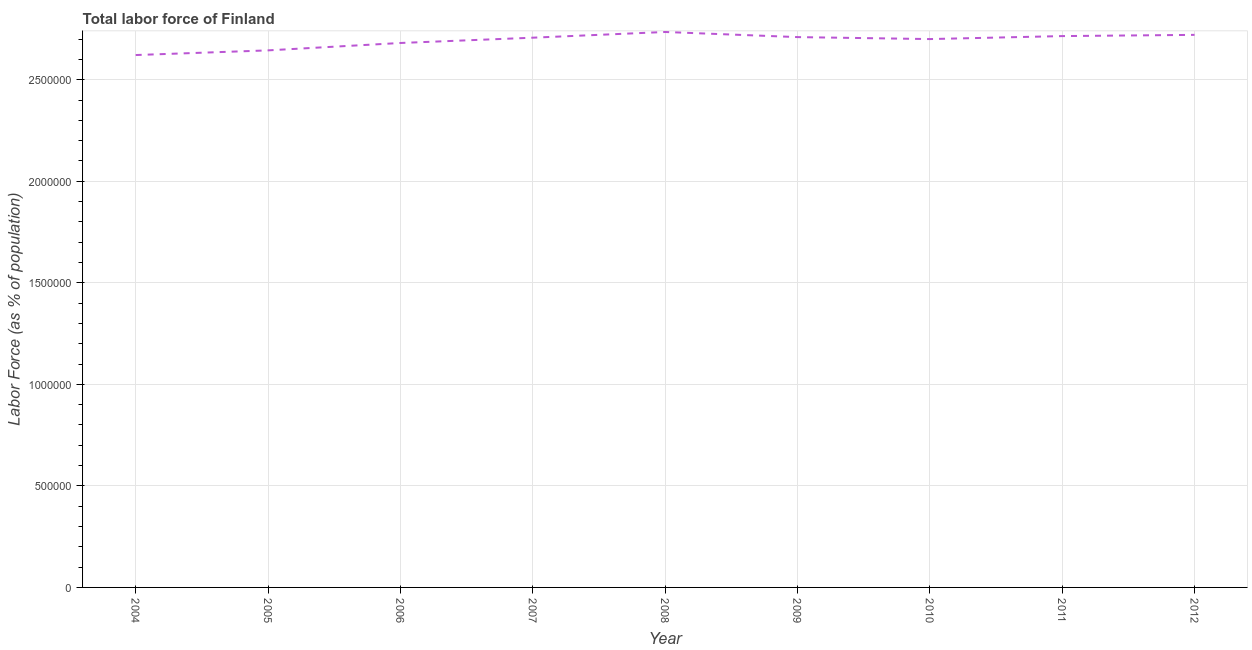What is the total labor force in 2010?
Provide a succinct answer. 2.70e+06. Across all years, what is the maximum total labor force?
Provide a succinct answer. 2.74e+06. Across all years, what is the minimum total labor force?
Offer a very short reply. 2.62e+06. In which year was the total labor force maximum?
Make the answer very short. 2008. What is the sum of the total labor force?
Offer a terse response. 2.42e+07. What is the difference between the total labor force in 2006 and 2011?
Keep it short and to the point. -3.40e+04. What is the average total labor force per year?
Offer a very short reply. 2.69e+06. What is the median total labor force?
Provide a short and direct response. 2.71e+06. In how many years, is the total labor force greater than 2300000 %?
Make the answer very short. 9. What is the ratio of the total labor force in 2005 to that in 2006?
Give a very brief answer. 0.99. Is the total labor force in 2009 less than that in 2010?
Offer a very short reply. No. What is the difference between the highest and the second highest total labor force?
Offer a terse response. 1.42e+04. Is the sum of the total labor force in 2007 and 2009 greater than the maximum total labor force across all years?
Provide a succinct answer. Yes. What is the difference between the highest and the lowest total labor force?
Ensure brevity in your answer.  1.14e+05. In how many years, is the total labor force greater than the average total labor force taken over all years?
Provide a short and direct response. 6. Does the total labor force monotonically increase over the years?
Provide a short and direct response. No. How many lines are there?
Your answer should be compact. 1. Are the values on the major ticks of Y-axis written in scientific E-notation?
Your answer should be very brief. No. What is the title of the graph?
Provide a short and direct response. Total labor force of Finland. What is the label or title of the Y-axis?
Offer a terse response. Labor Force (as % of population). What is the Labor Force (as % of population) in 2004?
Offer a very short reply. 2.62e+06. What is the Labor Force (as % of population) of 2005?
Keep it short and to the point. 2.64e+06. What is the Labor Force (as % of population) of 2006?
Keep it short and to the point. 2.68e+06. What is the Labor Force (as % of population) in 2007?
Offer a terse response. 2.71e+06. What is the Labor Force (as % of population) of 2008?
Provide a succinct answer. 2.74e+06. What is the Labor Force (as % of population) in 2009?
Offer a terse response. 2.71e+06. What is the Labor Force (as % of population) of 2010?
Give a very brief answer. 2.70e+06. What is the Labor Force (as % of population) of 2011?
Provide a succinct answer. 2.71e+06. What is the Labor Force (as % of population) in 2012?
Make the answer very short. 2.72e+06. What is the difference between the Labor Force (as % of population) in 2004 and 2005?
Your answer should be very brief. -2.30e+04. What is the difference between the Labor Force (as % of population) in 2004 and 2006?
Provide a succinct answer. -5.94e+04. What is the difference between the Labor Force (as % of population) in 2004 and 2007?
Your response must be concise. -8.54e+04. What is the difference between the Labor Force (as % of population) in 2004 and 2008?
Your response must be concise. -1.14e+05. What is the difference between the Labor Force (as % of population) in 2004 and 2009?
Give a very brief answer. -8.84e+04. What is the difference between the Labor Force (as % of population) in 2004 and 2010?
Provide a short and direct response. -7.87e+04. What is the difference between the Labor Force (as % of population) in 2004 and 2011?
Provide a succinct answer. -9.34e+04. What is the difference between the Labor Force (as % of population) in 2004 and 2012?
Give a very brief answer. -9.94e+04. What is the difference between the Labor Force (as % of population) in 2005 and 2006?
Provide a succinct answer. -3.64e+04. What is the difference between the Labor Force (as % of population) in 2005 and 2007?
Offer a terse response. -6.25e+04. What is the difference between the Labor Force (as % of population) in 2005 and 2008?
Give a very brief answer. -9.06e+04. What is the difference between the Labor Force (as % of population) in 2005 and 2009?
Give a very brief answer. -6.54e+04. What is the difference between the Labor Force (as % of population) in 2005 and 2010?
Offer a very short reply. -5.57e+04. What is the difference between the Labor Force (as % of population) in 2005 and 2011?
Provide a succinct answer. -7.04e+04. What is the difference between the Labor Force (as % of population) in 2005 and 2012?
Make the answer very short. -7.64e+04. What is the difference between the Labor Force (as % of population) in 2006 and 2007?
Offer a very short reply. -2.61e+04. What is the difference between the Labor Force (as % of population) in 2006 and 2008?
Your answer should be compact. -5.42e+04. What is the difference between the Labor Force (as % of population) in 2006 and 2009?
Your response must be concise. -2.90e+04. What is the difference between the Labor Force (as % of population) in 2006 and 2010?
Your answer should be compact. -1.93e+04. What is the difference between the Labor Force (as % of population) in 2006 and 2011?
Offer a very short reply. -3.40e+04. What is the difference between the Labor Force (as % of population) in 2006 and 2012?
Ensure brevity in your answer.  -4.00e+04. What is the difference between the Labor Force (as % of population) in 2007 and 2008?
Your response must be concise. -2.81e+04. What is the difference between the Labor Force (as % of population) in 2007 and 2009?
Provide a succinct answer. -2926. What is the difference between the Labor Force (as % of population) in 2007 and 2010?
Your answer should be very brief. 6793. What is the difference between the Labor Force (as % of population) in 2007 and 2011?
Provide a short and direct response. -7920. What is the difference between the Labor Force (as % of population) in 2007 and 2012?
Offer a terse response. -1.39e+04. What is the difference between the Labor Force (as % of population) in 2008 and 2009?
Give a very brief answer. 2.52e+04. What is the difference between the Labor Force (as % of population) in 2008 and 2010?
Your answer should be very brief. 3.49e+04. What is the difference between the Labor Force (as % of population) in 2008 and 2011?
Provide a succinct answer. 2.02e+04. What is the difference between the Labor Force (as % of population) in 2008 and 2012?
Provide a short and direct response. 1.42e+04. What is the difference between the Labor Force (as % of population) in 2009 and 2010?
Provide a succinct answer. 9719. What is the difference between the Labor Force (as % of population) in 2009 and 2011?
Ensure brevity in your answer.  -4994. What is the difference between the Labor Force (as % of population) in 2009 and 2012?
Your response must be concise. -1.10e+04. What is the difference between the Labor Force (as % of population) in 2010 and 2011?
Your answer should be very brief. -1.47e+04. What is the difference between the Labor Force (as % of population) in 2010 and 2012?
Keep it short and to the point. -2.07e+04. What is the difference between the Labor Force (as % of population) in 2011 and 2012?
Your response must be concise. -6010. What is the ratio of the Labor Force (as % of population) in 2004 to that in 2006?
Offer a terse response. 0.98. What is the ratio of the Labor Force (as % of population) in 2004 to that in 2007?
Make the answer very short. 0.97. What is the ratio of the Labor Force (as % of population) in 2004 to that in 2008?
Your answer should be very brief. 0.96. What is the ratio of the Labor Force (as % of population) in 2004 to that in 2009?
Provide a succinct answer. 0.97. What is the ratio of the Labor Force (as % of population) in 2004 to that in 2010?
Keep it short and to the point. 0.97. What is the ratio of the Labor Force (as % of population) in 2004 to that in 2011?
Make the answer very short. 0.97. What is the ratio of the Labor Force (as % of population) in 2005 to that in 2006?
Offer a very short reply. 0.99. What is the ratio of the Labor Force (as % of population) in 2005 to that in 2007?
Your answer should be very brief. 0.98. What is the ratio of the Labor Force (as % of population) in 2005 to that in 2008?
Provide a short and direct response. 0.97. What is the ratio of the Labor Force (as % of population) in 2005 to that in 2010?
Provide a succinct answer. 0.98. What is the ratio of the Labor Force (as % of population) in 2005 to that in 2011?
Offer a very short reply. 0.97. What is the ratio of the Labor Force (as % of population) in 2005 to that in 2012?
Make the answer very short. 0.97. What is the ratio of the Labor Force (as % of population) in 2006 to that in 2009?
Offer a terse response. 0.99. What is the ratio of the Labor Force (as % of population) in 2006 to that in 2010?
Give a very brief answer. 0.99. What is the ratio of the Labor Force (as % of population) in 2006 to that in 2012?
Your answer should be compact. 0.98. What is the ratio of the Labor Force (as % of population) in 2007 to that in 2009?
Your answer should be very brief. 1. What is the ratio of the Labor Force (as % of population) in 2007 to that in 2012?
Provide a short and direct response. 0.99. What is the ratio of the Labor Force (as % of population) in 2008 to that in 2009?
Offer a very short reply. 1.01. What is the ratio of the Labor Force (as % of population) in 2008 to that in 2010?
Ensure brevity in your answer.  1.01. What is the ratio of the Labor Force (as % of population) in 2010 to that in 2011?
Your answer should be compact. 0.99. 